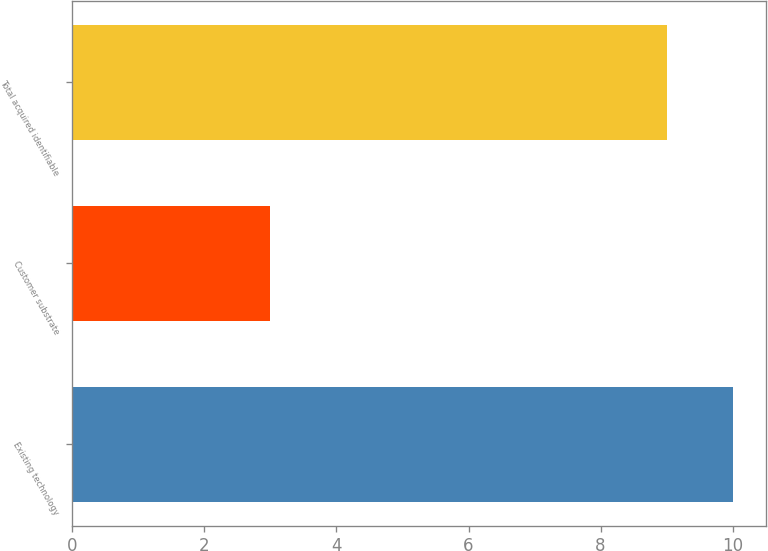Convert chart. <chart><loc_0><loc_0><loc_500><loc_500><bar_chart><fcel>Existing technology<fcel>Customer substrate<fcel>Total acquired identifiable<nl><fcel>10<fcel>3<fcel>9<nl></chart> 